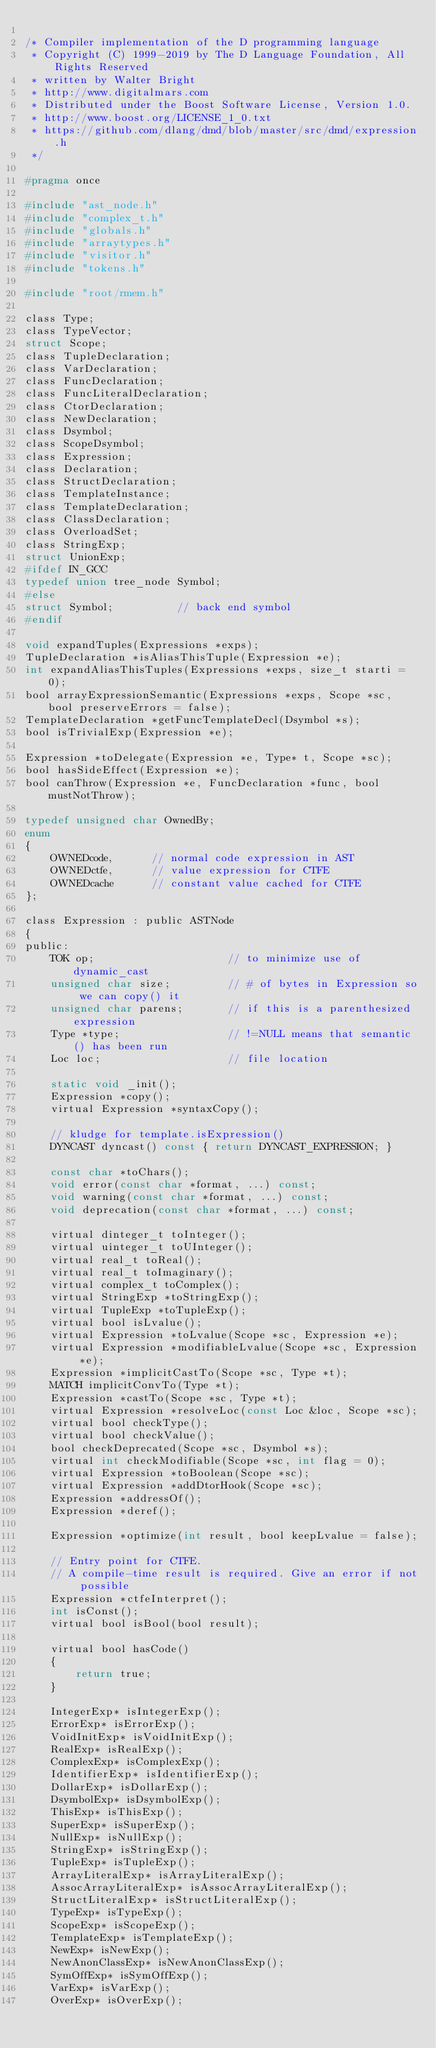Convert code to text. <code><loc_0><loc_0><loc_500><loc_500><_C_>
/* Compiler implementation of the D programming language
 * Copyright (C) 1999-2019 by The D Language Foundation, All Rights Reserved
 * written by Walter Bright
 * http://www.digitalmars.com
 * Distributed under the Boost Software License, Version 1.0.
 * http://www.boost.org/LICENSE_1_0.txt
 * https://github.com/dlang/dmd/blob/master/src/dmd/expression.h
 */

#pragma once

#include "ast_node.h"
#include "complex_t.h"
#include "globals.h"
#include "arraytypes.h"
#include "visitor.h"
#include "tokens.h"

#include "root/rmem.h"

class Type;
class TypeVector;
struct Scope;
class TupleDeclaration;
class VarDeclaration;
class FuncDeclaration;
class FuncLiteralDeclaration;
class CtorDeclaration;
class NewDeclaration;
class Dsymbol;
class ScopeDsymbol;
class Expression;
class Declaration;
class StructDeclaration;
class TemplateInstance;
class TemplateDeclaration;
class ClassDeclaration;
class OverloadSet;
class StringExp;
struct UnionExp;
#ifdef IN_GCC
typedef union tree_node Symbol;
#else
struct Symbol;          // back end symbol
#endif

void expandTuples(Expressions *exps);
TupleDeclaration *isAliasThisTuple(Expression *e);
int expandAliasThisTuples(Expressions *exps, size_t starti = 0);
bool arrayExpressionSemantic(Expressions *exps, Scope *sc, bool preserveErrors = false);
TemplateDeclaration *getFuncTemplateDecl(Dsymbol *s);
bool isTrivialExp(Expression *e);

Expression *toDelegate(Expression *e, Type* t, Scope *sc);
bool hasSideEffect(Expression *e);
bool canThrow(Expression *e, FuncDeclaration *func, bool mustNotThrow);

typedef unsigned char OwnedBy;
enum
{
    OWNEDcode,      // normal code expression in AST
    OWNEDctfe,      // value expression for CTFE
    OWNEDcache      // constant value cached for CTFE
};

class Expression : public ASTNode
{
public:
    TOK op;                     // to minimize use of dynamic_cast
    unsigned char size;         // # of bytes in Expression so we can copy() it
    unsigned char parens;       // if this is a parenthesized expression
    Type *type;                 // !=NULL means that semantic() has been run
    Loc loc;                    // file location

    static void _init();
    Expression *copy();
    virtual Expression *syntaxCopy();

    // kludge for template.isExpression()
    DYNCAST dyncast() const { return DYNCAST_EXPRESSION; }

    const char *toChars();
    void error(const char *format, ...) const;
    void warning(const char *format, ...) const;
    void deprecation(const char *format, ...) const;

    virtual dinteger_t toInteger();
    virtual uinteger_t toUInteger();
    virtual real_t toReal();
    virtual real_t toImaginary();
    virtual complex_t toComplex();
    virtual StringExp *toStringExp();
    virtual TupleExp *toTupleExp();
    virtual bool isLvalue();
    virtual Expression *toLvalue(Scope *sc, Expression *e);
    virtual Expression *modifiableLvalue(Scope *sc, Expression *e);
    Expression *implicitCastTo(Scope *sc, Type *t);
    MATCH implicitConvTo(Type *t);
    Expression *castTo(Scope *sc, Type *t);
    virtual Expression *resolveLoc(const Loc &loc, Scope *sc);
    virtual bool checkType();
    virtual bool checkValue();
    bool checkDeprecated(Scope *sc, Dsymbol *s);
    virtual int checkModifiable(Scope *sc, int flag = 0);
    virtual Expression *toBoolean(Scope *sc);
    virtual Expression *addDtorHook(Scope *sc);
    Expression *addressOf();
    Expression *deref();

    Expression *optimize(int result, bool keepLvalue = false);

    // Entry point for CTFE.
    // A compile-time result is required. Give an error if not possible
    Expression *ctfeInterpret();
    int isConst();
    virtual bool isBool(bool result);

    virtual bool hasCode()
    {
        return true;
    }

    IntegerExp* isIntegerExp();
    ErrorExp* isErrorExp();
    VoidInitExp* isVoidInitExp();
    RealExp* isRealExp();
    ComplexExp* isComplexExp();
    IdentifierExp* isIdentifierExp();
    DollarExp* isDollarExp();
    DsymbolExp* isDsymbolExp();
    ThisExp* isThisExp();
    SuperExp* isSuperExp();
    NullExp* isNullExp();
    StringExp* isStringExp();
    TupleExp* isTupleExp();
    ArrayLiteralExp* isArrayLiteralExp();
    AssocArrayLiteralExp* isAssocArrayLiteralExp();
    StructLiteralExp* isStructLiteralExp();
    TypeExp* isTypeExp();
    ScopeExp* isScopeExp();
    TemplateExp* isTemplateExp();
    NewExp* isNewExp();
    NewAnonClassExp* isNewAnonClassExp();
    SymOffExp* isSymOffExp();
    VarExp* isVarExp();
    OverExp* isOverExp();</code> 